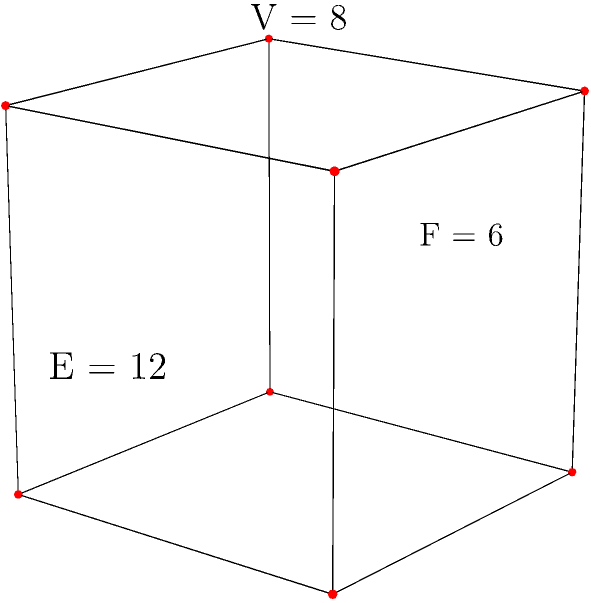As a writer known for in-depth research, you're exploring the Euler characteristic of polyhedra for a new book. Given the cube shown in the diagram, with 8 vertices (V), 12 edges (E), and 6 faces (F), calculate its Euler characteristic. How does this result relate to other convex polyhedra, and what is its significance in topology? To answer this question, let's follow these steps:

1. Calculate the Euler characteristic:
   The Euler characteristic (χ) is defined as χ = V - E + F, where:
   V = number of vertices
   E = number of edges
   F = number of faces

   For the given cube:
   V = 8
   E = 12
   F = 6

   χ = V - E + F
   χ = 8 - 12 + 6
   χ = 2

2. Relation to other convex polyhedra:
   The Euler characteristic of 2 is not unique to the cube. In fact, all convex polyhedra have an Euler characteristic of 2. This is known as Euler's polyhedron formula or Euler's characteristic for polyhedra.

3. Significance in topology:
   The Euler characteristic is a topological invariant, meaning it remains constant under continuous deformations of the shape. This property makes it a fundamental concept in topology.

   For any convex polyhedron:
   - It can be continuously deformed into a sphere without changing its Euler characteristic.
   - The Euler characteristic of 2 is preserved regardless of the number of vertices, edges, or faces.

   This concept extends beyond polyhedra to more complex topological spaces:
   - For a sphere or any shape that can be continuously deformed into a sphere (like all convex polyhedra), χ = 2
   - For a torus, χ = 0
   - For a double torus, χ = -2

   The Euler characteristic helps classify topological spaces and is crucial in various branches of mathematics, including algebraic topology and differential geometry.
Answer: Euler characteristic: 2; invariant for convex polyhedra; classifies topological spaces 